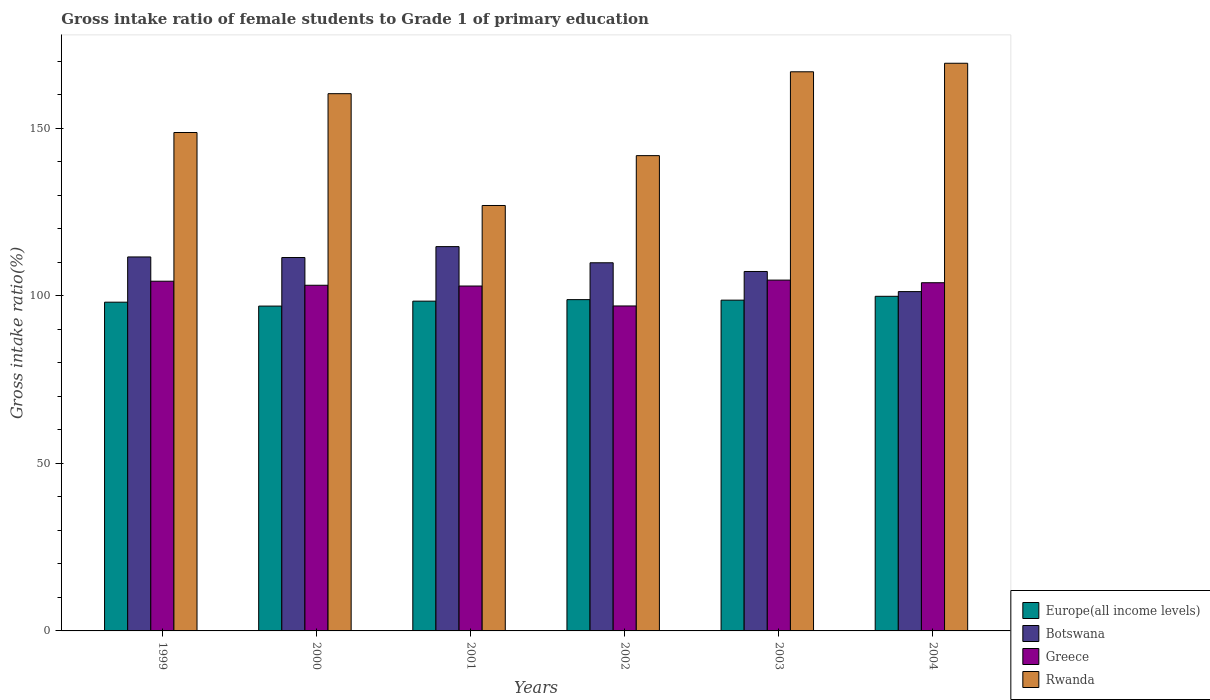How many groups of bars are there?
Offer a very short reply. 6. Are the number of bars on each tick of the X-axis equal?
Offer a very short reply. Yes. What is the label of the 5th group of bars from the left?
Keep it short and to the point. 2003. What is the gross intake ratio in Botswana in 2004?
Provide a succinct answer. 101.23. Across all years, what is the maximum gross intake ratio in Rwanda?
Ensure brevity in your answer.  169.36. Across all years, what is the minimum gross intake ratio in Greece?
Your response must be concise. 96.95. In which year was the gross intake ratio in Europe(all income levels) minimum?
Your answer should be compact. 2000. What is the total gross intake ratio in Botswana in the graph?
Offer a terse response. 655.95. What is the difference between the gross intake ratio in Botswana in 1999 and that in 2002?
Keep it short and to the point. 1.74. What is the difference between the gross intake ratio in Europe(all income levels) in 2001 and the gross intake ratio in Rwanda in 2002?
Offer a very short reply. -43.42. What is the average gross intake ratio in Botswana per year?
Your answer should be very brief. 109.32. In the year 1999, what is the difference between the gross intake ratio in Rwanda and gross intake ratio in Botswana?
Your answer should be very brief. 37.12. In how many years, is the gross intake ratio in Greece greater than 70 %?
Provide a succinct answer. 6. What is the ratio of the gross intake ratio in Rwanda in 2000 to that in 2004?
Provide a short and direct response. 0.95. What is the difference between the highest and the second highest gross intake ratio in Rwanda?
Ensure brevity in your answer.  2.54. What is the difference between the highest and the lowest gross intake ratio in Botswana?
Give a very brief answer. 13.42. What does the 3rd bar from the left in 2004 represents?
Ensure brevity in your answer.  Greece. What does the 1st bar from the right in 2001 represents?
Give a very brief answer. Rwanda. Is it the case that in every year, the sum of the gross intake ratio in Rwanda and gross intake ratio in Greece is greater than the gross intake ratio in Botswana?
Make the answer very short. Yes. How many years are there in the graph?
Ensure brevity in your answer.  6. Are the values on the major ticks of Y-axis written in scientific E-notation?
Your response must be concise. No. How many legend labels are there?
Give a very brief answer. 4. How are the legend labels stacked?
Ensure brevity in your answer.  Vertical. What is the title of the graph?
Your answer should be very brief. Gross intake ratio of female students to Grade 1 of primary education. Does "Papua New Guinea" appear as one of the legend labels in the graph?
Ensure brevity in your answer.  No. What is the label or title of the X-axis?
Your response must be concise. Years. What is the label or title of the Y-axis?
Make the answer very short. Gross intake ratio(%). What is the Gross intake ratio(%) in Europe(all income levels) in 1999?
Provide a succinct answer. 98.08. What is the Gross intake ratio(%) of Botswana in 1999?
Provide a succinct answer. 111.58. What is the Gross intake ratio(%) of Greece in 1999?
Provide a short and direct response. 104.33. What is the Gross intake ratio(%) in Rwanda in 1999?
Give a very brief answer. 148.7. What is the Gross intake ratio(%) in Europe(all income levels) in 2000?
Offer a very short reply. 96.91. What is the Gross intake ratio(%) in Botswana in 2000?
Offer a very short reply. 111.4. What is the Gross intake ratio(%) of Greece in 2000?
Provide a succinct answer. 103.13. What is the Gross intake ratio(%) in Rwanda in 2000?
Keep it short and to the point. 160.29. What is the Gross intake ratio(%) in Europe(all income levels) in 2001?
Provide a short and direct response. 98.39. What is the Gross intake ratio(%) in Botswana in 2001?
Keep it short and to the point. 114.66. What is the Gross intake ratio(%) of Greece in 2001?
Provide a succinct answer. 102.9. What is the Gross intake ratio(%) of Rwanda in 2001?
Provide a short and direct response. 126.92. What is the Gross intake ratio(%) in Europe(all income levels) in 2002?
Give a very brief answer. 98.84. What is the Gross intake ratio(%) of Botswana in 2002?
Offer a terse response. 109.84. What is the Gross intake ratio(%) of Greece in 2002?
Your answer should be very brief. 96.95. What is the Gross intake ratio(%) in Rwanda in 2002?
Make the answer very short. 141.8. What is the Gross intake ratio(%) in Europe(all income levels) in 2003?
Make the answer very short. 98.68. What is the Gross intake ratio(%) of Botswana in 2003?
Your answer should be compact. 107.24. What is the Gross intake ratio(%) of Greece in 2003?
Ensure brevity in your answer.  104.67. What is the Gross intake ratio(%) in Rwanda in 2003?
Ensure brevity in your answer.  166.82. What is the Gross intake ratio(%) of Europe(all income levels) in 2004?
Offer a very short reply. 99.83. What is the Gross intake ratio(%) of Botswana in 2004?
Keep it short and to the point. 101.23. What is the Gross intake ratio(%) of Greece in 2004?
Ensure brevity in your answer.  103.89. What is the Gross intake ratio(%) of Rwanda in 2004?
Make the answer very short. 169.36. Across all years, what is the maximum Gross intake ratio(%) in Europe(all income levels)?
Your answer should be compact. 99.83. Across all years, what is the maximum Gross intake ratio(%) in Botswana?
Keep it short and to the point. 114.66. Across all years, what is the maximum Gross intake ratio(%) of Greece?
Provide a succinct answer. 104.67. Across all years, what is the maximum Gross intake ratio(%) of Rwanda?
Your answer should be compact. 169.36. Across all years, what is the minimum Gross intake ratio(%) in Europe(all income levels)?
Keep it short and to the point. 96.91. Across all years, what is the minimum Gross intake ratio(%) in Botswana?
Your answer should be compact. 101.23. Across all years, what is the minimum Gross intake ratio(%) in Greece?
Ensure brevity in your answer.  96.95. Across all years, what is the minimum Gross intake ratio(%) in Rwanda?
Your answer should be compact. 126.92. What is the total Gross intake ratio(%) in Europe(all income levels) in the graph?
Ensure brevity in your answer.  590.74. What is the total Gross intake ratio(%) of Botswana in the graph?
Offer a terse response. 655.95. What is the total Gross intake ratio(%) in Greece in the graph?
Your answer should be compact. 615.86. What is the total Gross intake ratio(%) of Rwanda in the graph?
Provide a short and direct response. 913.9. What is the difference between the Gross intake ratio(%) of Europe(all income levels) in 1999 and that in 2000?
Provide a short and direct response. 1.17. What is the difference between the Gross intake ratio(%) of Botswana in 1999 and that in 2000?
Make the answer very short. 0.17. What is the difference between the Gross intake ratio(%) of Greece in 1999 and that in 2000?
Provide a succinct answer. 1.21. What is the difference between the Gross intake ratio(%) of Rwanda in 1999 and that in 2000?
Give a very brief answer. -11.58. What is the difference between the Gross intake ratio(%) in Europe(all income levels) in 1999 and that in 2001?
Provide a short and direct response. -0.31. What is the difference between the Gross intake ratio(%) in Botswana in 1999 and that in 2001?
Make the answer very short. -3.08. What is the difference between the Gross intake ratio(%) in Greece in 1999 and that in 2001?
Give a very brief answer. 1.44. What is the difference between the Gross intake ratio(%) of Rwanda in 1999 and that in 2001?
Ensure brevity in your answer.  21.78. What is the difference between the Gross intake ratio(%) of Europe(all income levels) in 1999 and that in 2002?
Provide a succinct answer. -0.76. What is the difference between the Gross intake ratio(%) of Botswana in 1999 and that in 2002?
Keep it short and to the point. 1.74. What is the difference between the Gross intake ratio(%) of Greece in 1999 and that in 2002?
Offer a very short reply. 7.38. What is the difference between the Gross intake ratio(%) of Rwanda in 1999 and that in 2002?
Keep it short and to the point. 6.9. What is the difference between the Gross intake ratio(%) of Europe(all income levels) in 1999 and that in 2003?
Your answer should be compact. -0.6. What is the difference between the Gross intake ratio(%) in Botswana in 1999 and that in 2003?
Make the answer very short. 4.34. What is the difference between the Gross intake ratio(%) in Greece in 1999 and that in 2003?
Your response must be concise. -0.33. What is the difference between the Gross intake ratio(%) of Rwanda in 1999 and that in 2003?
Keep it short and to the point. -18.12. What is the difference between the Gross intake ratio(%) of Europe(all income levels) in 1999 and that in 2004?
Your answer should be very brief. -1.75. What is the difference between the Gross intake ratio(%) of Botswana in 1999 and that in 2004?
Your answer should be very brief. 10.34. What is the difference between the Gross intake ratio(%) in Greece in 1999 and that in 2004?
Ensure brevity in your answer.  0.45. What is the difference between the Gross intake ratio(%) in Rwanda in 1999 and that in 2004?
Your answer should be compact. -20.66. What is the difference between the Gross intake ratio(%) of Europe(all income levels) in 2000 and that in 2001?
Your answer should be compact. -1.47. What is the difference between the Gross intake ratio(%) in Botswana in 2000 and that in 2001?
Your response must be concise. -3.25. What is the difference between the Gross intake ratio(%) in Greece in 2000 and that in 2001?
Keep it short and to the point. 0.23. What is the difference between the Gross intake ratio(%) of Rwanda in 2000 and that in 2001?
Make the answer very short. 33.36. What is the difference between the Gross intake ratio(%) of Europe(all income levels) in 2000 and that in 2002?
Keep it short and to the point. -1.92. What is the difference between the Gross intake ratio(%) of Botswana in 2000 and that in 2002?
Keep it short and to the point. 1.57. What is the difference between the Gross intake ratio(%) of Greece in 2000 and that in 2002?
Offer a terse response. 6.18. What is the difference between the Gross intake ratio(%) of Rwanda in 2000 and that in 2002?
Make the answer very short. 18.48. What is the difference between the Gross intake ratio(%) of Europe(all income levels) in 2000 and that in 2003?
Your answer should be very brief. -1.77. What is the difference between the Gross intake ratio(%) in Botswana in 2000 and that in 2003?
Your response must be concise. 4.16. What is the difference between the Gross intake ratio(%) of Greece in 2000 and that in 2003?
Your answer should be very brief. -1.54. What is the difference between the Gross intake ratio(%) of Rwanda in 2000 and that in 2003?
Provide a short and direct response. -6.53. What is the difference between the Gross intake ratio(%) of Europe(all income levels) in 2000 and that in 2004?
Ensure brevity in your answer.  -2.92. What is the difference between the Gross intake ratio(%) of Botswana in 2000 and that in 2004?
Give a very brief answer. 10.17. What is the difference between the Gross intake ratio(%) of Greece in 2000 and that in 2004?
Ensure brevity in your answer.  -0.76. What is the difference between the Gross intake ratio(%) in Rwanda in 2000 and that in 2004?
Keep it short and to the point. -9.08. What is the difference between the Gross intake ratio(%) of Europe(all income levels) in 2001 and that in 2002?
Offer a terse response. -0.45. What is the difference between the Gross intake ratio(%) of Botswana in 2001 and that in 2002?
Your answer should be very brief. 4.82. What is the difference between the Gross intake ratio(%) in Greece in 2001 and that in 2002?
Offer a very short reply. 5.95. What is the difference between the Gross intake ratio(%) of Rwanda in 2001 and that in 2002?
Ensure brevity in your answer.  -14.88. What is the difference between the Gross intake ratio(%) in Europe(all income levels) in 2001 and that in 2003?
Your answer should be compact. -0.3. What is the difference between the Gross intake ratio(%) of Botswana in 2001 and that in 2003?
Your response must be concise. 7.42. What is the difference between the Gross intake ratio(%) in Greece in 2001 and that in 2003?
Keep it short and to the point. -1.77. What is the difference between the Gross intake ratio(%) of Rwanda in 2001 and that in 2003?
Offer a terse response. -39.89. What is the difference between the Gross intake ratio(%) in Europe(all income levels) in 2001 and that in 2004?
Your answer should be very brief. -1.45. What is the difference between the Gross intake ratio(%) in Botswana in 2001 and that in 2004?
Give a very brief answer. 13.42. What is the difference between the Gross intake ratio(%) of Greece in 2001 and that in 2004?
Provide a short and direct response. -0.99. What is the difference between the Gross intake ratio(%) in Rwanda in 2001 and that in 2004?
Ensure brevity in your answer.  -42.44. What is the difference between the Gross intake ratio(%) in Europe(all income levels) in 2002 and that in 2003?
Your answer should be very brief. 0.15. What is the difference between the Gross intake ratio(%) of Botswana in 2002 and that in 2003?
Give a very brief answer. 2.6. What is the difference between the Gross intake ratio(%) of Greece in 2002 and that in 2003?
Provide a succinct answer. -7.72. What is the difference between the Gross intake ratio(%) in Rwanda in 2002 and that in 2003?
Offer a terse response. -25.01. What is the difference between the Gross intake ratio(%) in Europe(all income levels) in 2002 and that in 2004?
Offer a terse response. -0.99. What is the difference between the Gross intake ratio(%) in Botswana in 2002 and that in 2004?
Keep it short and to the point. 8.6. What is the difference between the Gross intake ratio(%) in Greece in 2002 and that in 2004?
Your response must be concise. -6.94. What is the difference between the Gross intake ratio(%) of Rwanda in 2002 and that in 2004?
Offer a very short reply. -27.56. What is the difference between the Gross intake ratio(%) of Europe(all income levels) in 2003 and that in 2004?
Your answer should be compact. -1.15. What is the difference between the Gross intake ratio(%) in Botswana in 2003 and that in 2004?
Your response must be concise. 6. What is the difference between the Gross intake ratio(%) of Greece in 2003 and that in 2004?
Offer a very short reply. 0.78. What is the difference between the Gross intake ratio(%) in Rwanda in 2003 and that in 2004?
Offer a terse response. -2.54. What is the difference between the Gross intake ratio(%) of Europe(all income levels) in 1999 and the Gross intake ratio(%) of Botswana in 2000?
Your answer should be compact. -13.32. What is the difference between the Gross intake ratio(%) in Europe(all income levels) in 1999 and the Gross intake ratio(%) in Greece in 2000?
Make the answer very short. -5.05. What is the difference between the Gross intake ratio(%) in Europe(all income levels) in 1999 and the Gross intake ratio(%) in Rwanda in 2000?
Give a very brief answer. -62.21. What is the difference between the Gross intake ratio(%) in Botswana in 1999 and the Gross intake ratio(%) in Greece in 2000?
Provide a succinct answer. 8.45. What is the difference between the Gross intake ratio(%) in Botswana in 1999 and the Gross intake ratio(%) in Rwanda in 2000?
Make the answer very short. -48.71. What is the difference between the Gross intake ratio(%) in Greece in 1999 and the Gross intake ratio(%) in Rwanda in 2000?
Provide a succinct answer. -55.95. What is the difference between the Gross intake ratio(%) of Europe(all income levels) in 1999 and the Gross intake ratio(%) of Botswana in 2001?
Give a very brief answer. -16.58. What is the difference between the Gross intake ratio(%) of Europe(all income levels) in 1999 and the Gross intake ratio(%) of Greece in 2001?
Offer a very short reply. -4.82. What is the difference between the Gross intake ratio(%) in Europe(all income levels) in 1999 and the Gross intake ratio(%) in Rwanda in 2001?
Provide a short and direct response. -28.84. What is the difference between the Gross intake ratio(%) in Botswana in 1999 and the Gross intake ratio(%) in Greece in 2001?
Keep it short and to the point. 8.68. What is the difference between the Gross intake ratio(%) of Botswana in 1999 and the Gross intake ratio(%) of Rwanda in 2001?
Your answer should be compact. -15.35. What is the difference between the Gross intake ratio(%) of Greece in 1999 and the Gross intake ratio(%) of Rwanda in 2001?
Give a very brief answer. -22.59. What is the difference between the Gross intake ratio(%) in Europe(all income levels) in 1999 and the Gross intake ratio(%) in Botswana in 2002?
Ensure brevity in your answer.  -11.76. What is the difference between the Gross intake ratio(%) in Europe(all income levels) in 1999 and the Gross intake ratio(%) in Greece in 2002?
Offer a very short reply. 1.13. What is the difference between the Gross intake ratio(%) of Europe(all income levels) in 1999 and the Gross intake ratio(%) of Rwanda in 2002?
Give a very brief answer. -43.72. What is the difference between the Gross intake ratio(%) of Botswana in 1999 and the Gross intake ratio(%) of Greece in 2002?
Provide a succinct answer. 14.63. What is the difference between the Gross intake ratio(%) in Botswana in 1999 and the Gross intake ratio(%) in Rwanda in 2002?
Your answer should be very brief. -30.23. What is the difference between the Gross intake ratio(%) of Greece in 1999 and the Gross intake ratio(%) of Rwanda in 2002?
Offer a very short reply. -37.47. What is the difference between the Gross intake ratio(%) of Europe(all income levels) in 1999 and the Gross intake ratio(%) of Botswana in 2003?
Your answer should be very brief. -9.16. What is the difference between the Gross intake ratio(%) of Europe(all income levels) in 1999 and the Gross intake ratio(%) of Greece in 2003?
Your answer should be compact. -6.59. What is the difference between the Gross intake ratio(%) in Europe(all income levels) in 1999 and the Gross intake ratio(%) in Rwanda in 2003?
Make the answer very short. -68.74. What is the difference between the Gross intake ratio(%) in Botswana in 1999 and the Gross intake ratio(%) in Greece in 2003?
Give a very brief answer. 6.91. What is the difference between the Gross intake ratio(%) of Botswana in 1999 and the Gross intake ratio(%) of Rwanda in 2003?
Your response must be concise. -55.24. What is the difference between the Gross intake ratio(%) of Greece in 1999 and the Gross intake ratio(%) of Rwanda in 2003?
Provide a succinct answer. -62.48. What is the difference between the Gross intake ratio(%) of Europe(all income levels) in 1999 and the Gross intake ratio(%) of Botswana in 2004?
Make the answer very short. -3.15. What is the difference between the Gross intake ratio(%) in Europe(all income levels) in 1999 and the Gross intake ratio(%) in Greece in 2004?
Offer a terse response. -5.8. What is the difference between the Gross intake ratio(%) of Europe(all income levels) in 1999 and the Gross intake ratio(%) of Rwanda in 2004?
Make the answer very short. -71.28. What is the difference between the Gross intake ratio(%) in Botswana in 1999 and the Gross intake ratio(%) in Greece in 2004?
Provide a succinct answer. 7.69. What is the difference between the Gross intake ratio(%) of Botswana in 1999 and the Gross intake ratio(%) of Rwanda in 2004?
Ensure brevity in your answer.  -57.78. What is the difference between the Gross intake ratio(%) in Greece in 1999 and the Gross intake ratio(%) in Rwanda in 2004?
Give a very brief answer. -65.03. What is the difference between the Gross intake ratio(%) of Europe(all income levels) in 2000 and the Gross intake ratio(%) of Botswana in 2001?
Make the answer very short. -17.74. What is the difference between the Gross intake ratio(%) of Europe(all income levels) in 2000 and the Gross intake ratio(%) of Greece in 2001?
Ensure brevity in your answer.  -5.98. What is the difference between the Gross intake ratio(%) in Europe(all income levels) in 2000 and the Gross intake ratio(%) in Rwanda in 2001?
Make the answer very short. -30.01. What is the difference between the Gross intake ratio(%) in Botswana in 2000 and the Gross intake ratio(%) in Greece in 2001?
Give a very brief answer. 8.5. What is the difference between the Gross intake ratio(%) in Botswana in 2000 and the Gross intake ratio(%) in Rwanda in 2001?
Your answer should be compact. -15.52. What is the difference between the Gross intake ratio(%) in Greece in 2000 and the Gross intake ratio(%) in Rwanda in 2001?
Offer a very short reply. -23.8. What is the difference between the Gross intake ratio(%) in Europe(all income levels) in 2000 and the Gross intake ratio(%) in Botswana in 2002?
Ensure brevity in your answer.  -12.92. What is the difference between the Gross intake ratio(%) of Europe(all income levels) in 2000 and the Gross intake ratio(%) of Greece in 2002?
Your response must be concise. -0.04. What is the difference between the Gross intake ratio(%) in Europe(all income levels) in 2000 and the Gross intake ratio(%) in Rwanda in 2002?
Give a very brief answer. -44.89. What is the difference between the Gross intake ratio(%) in Botswana in 2000 and the Gross intake ratio(%) in Greece in 2002?
Provide a short and direct response. 14.45. What is the difference between the Gross intake ratio(%) of Botswana in 2000 and the Gross intake ratio(%) of Rwanda in 2002?
Ensure brevity in your answer.  -30.4. What is the difference between the Gross intake ratio(%) of Greece in 2000 and the Gross intake ratio(%) of Rwanda in 2002?
Offer a terse response. -38.67. What is the difference between the Gross intake ratio(%) of Europe(all income levels) in 2000 and the Gross intake ratio(%) of Botswana in 2003?
Ensure brevity in your answer.  -10.32. What is the difference between the Gross intake ratio(%) in Europe(all income levels) in 2000 and the Gross intake ratio(%) in Greece in 2003?
Provide a short and direct response. -7.75. What is the difference between the Gross intake ratio(%) of Europe(all income levels) in 2000 and the Gross intake ratio(%) of Rwanda in 2003?
Make the answer very short. -69.9. What is the difference between the Gross intake ratio(%) in Botswana in 2000 and the Gross intake ratio(%) in Greece in 2003?
Your answer should be compact. 6.74. What is the difference between the Gross intake ratio(%) of Botswana in 2000 and the Gross intake ratio(%) of Rwanda in 2003?
Offer a very short reply. -55.41. What is the difference between the Gross intake ratio(%) in Greece in 2000 and the Gross intake ratio(%) in Rwanda in 2003?
Offer a very short reply. -63.69. What is the difference between the Gross intake ratio(%) in Europe(all income levels) in 2000 and the Gross intake ratio(%) in Botswana in 2004?
Offer a very short reply. -4.32. What is the difference between the Gross intake ratio(%) in Europe(all income levels) in 2000 and the Gross intake ratio(%) in Greece in 2004?
Your answer should be compact. -6.97. What is the difference between the Gross intake ratio(%) in Europe(all income levels) in 2000 and the Gross intake ratio(%) in Rwanda in 2004?
Your response must be concise. -72.45. What is the difference between the Gross intake ratio(%) of Botswana in 2000 and the Gross intake ratio(%) of Greece in 2004?
Make the answer very short. 7.52. What is the difference between the Gross intake ratio(%) in Botswana in 2000 and the Gross intake ratio(%) in Rwanda in 2004?
Your response must be concise. -57.96. What is the difference between the Gross intake ratio(%) in Greece in 2000 and the Gross intake ratio(%) in Rwanda in 2004?
Provide a short and direct response. -66.23. What is the difference between the Gross intake ratio(%) of Europe(all income levels) in 2001 and the Gross intake ratio(%) of Botswana in 2002?
Offer a very short reply. -11.45. What is the difference between the Gross intake ratio(%) of Europe(all income levels) in 2001 and the Gross intake ratio(%) of Greece in 2002?
Your answer should be compact. 1.44. What is the difference between the Gross intake ratio(%) of Europe(all income levels) in 2001 and the Gross intake ratio(%) of Rwanda in 2002?
Offer a very short reply. -43.42. What is the difference between the Gross intake ratio(%) of Botswana in 2001 and the Gross intake ratio(%) of Greece in 2002?
Your answer should be very brief. 17.71. What is the difference between the Gross intake ratio(%) of Botswana in 2001 and the Gross intake ratio(%) of Rwanda in 2002?
Your answer should be very brief. -27.15. What is the difference between the Gross intake ratio(%) in Greece in 2001 and the Gross intake ratio(%) in Rwanda in 2002?
Ensure brevity in your answer.  -38.9. What is the difference between the Gross intake ratio(%) of Europe(all income levels) in 2001 and the Gross intake ratio(%) of Botswana in 2003?
Make the answer very short. -8.85. What is the difference between the Gross intake ratio(%) in Europe(all income levels) in 2001 and the Gross intake ratio(%) in Greece in 2003?
Your answer should be compact. -6.28. What is the difference between the Gross intake ratio(%) in Europe(all income levels) in 2001 and the Gross intake ratio(%) in Rwanda in 2003?
Give a very brief answer. -68.43. What is the difference between the Gross intake ratio(%) of Botswana in 2001 and the Gross intake ratio(%) of Greece in 2003?
Provide a short and direct response. 9.99. What is the difference between the Gross intake ratio(%) in Botswana in 2001 and the Gross intake ratio(%) in Rwanda in 2003?
Offer a terse response. -52.16. What is the difference between the Gross intake ratio(%) in Greece in 2001 and the Gross intake ratio(%) in Rwanda in 2003?
Provide a short and direct response. -63.92. What is the difference between the Gross intake ratio(%) in Europe(all income levels) in 2001 and the Gross intake ratio(%) in Botswana in 2004?
Provide a succinct answer. -2.85. What is the difference between the Gross intake ratio(%) in Europe(all income levels) in 2001 and the Gross intake ratio(%) in Greece in 2004?
Offer a terse response. -5.5. What is the difference between the Gross intake ratio(%) of Europe(all income levels) in 2001 and the Gross intake ratio(%) of Rwanda in 2004?
Offer a very short reply. -70.98. What is the difference between the Gross intake ratio(%) of Botswana in 2001 and the Gross intake ratio(%) of Greece in 2004?
Your response must be concise. 10.77. What is the difference between the Gross intake ratio(%) in Botswana in 2001 and the Gross intake ratio(%) in Rwanda in 2004?
Provide a succinct answer. -54.71. What is the difference between the Gross intake ratio(%) of Greece in 2001 and the Gross intake ratio(%) of Rwanda in 2004?
Keep it short and to the point. -66.46. What is the difference between the Gross intake ratio(%) of Europe(all income levels) in 2002 and the Gross intake ratio(%) of Botswana in 2003?
Ensure brevity in your answer.  -8.4. What is the difference between the Gross intake ratio(%) of Europe(all income levels) in 2002 and the Gross intake ratio(%) of Greece in 2003?
Offer a terse response. -5.83. What is the difference between the Gross intake ratio(%) in Europe(all income levels) in 2002 and the Gross intake ratio(%) in Rwanda in 2003?
Provide a short and direct response. -67.98. What is the difference between the Gross intake ratio(%) in Botswana in 2002 and the Gross intake ratio(%) in Greece in 2003?
Make the answer very short. 5.17. What is the difference between the Gross intake ratio(%) in Botswana in 2002 and the Gross intake ratio(%) in Rwanda in 2003?
Ensure brevity in your answer.  -56.98. What is the difference between the Gross intake ratio(%) of Greece in 2002 and the Gross intake ratio(%) of Rwanda in 2003?
Offer a terse response. -69.87. What is the difference between the Gross intake ratio(%) of Europe(all income levels) in 2002 and the Gross intake ratio(%) of Botswana in 2004?
Offer a terse response. -2.4. What is the difference between the Gross intake ratio(%) of Europe(all income levels) in 2002 and the Gross intake ratio(%) of Greece in 2004?
Keep it short and to the point. -5.05. What is the difference between the Gross intake ratio(%) of Europe(all income levels) in 2002 and the Gross intake ratio(%) of Rwanda in 2004?
Keep it short and to the point. -70.52. What is the difference between the Gross intake ratio(%) in Botswana in 2002 and the Gross intake ratio(%) in Greece in 2004?
Offer a terse response. 5.95. What is the difference between the Gross intake ratio(%) of Botswana in 2002 and the Gross intake ratio(%) of Rwanda in 2004?
Offer a terse response. -59.53. What is the difference between the Gross intake ratio(%) in Greece in 2002 and the Gross intake ratio(%) in Rwanda in 2004?
Ensure brevity in your answer.  -72.41. What is the difference between the Gross intake ratio(%) of Europe(all income levels) in 2003 and the Gross intake ratio(%) of Botswana in 2004?
Your answer should be compact. -2.55. What is the difference between the Gross intake ratio(%) of Europe(all income levels) in 2003 and the Gross intake ratio(%) of Greece in 2004?
Your answer should be very brief. -5.2. What is the difference between the Gross intake ratio(%) of Europe(all income levels) in 2003 and the Gross intake ratio(%) of Rwanda in 2004?
Your response must be concise. -70.68. What is the difference between the Gross intake ratio(%) of Botswana in 2003 and the Gross intake ratio(%) of Greece in 2004?
Your answer should be compact. 3.35. What is the difference between the Gross intake ratio(%) of Botswana in 2003 and the Gross intake ratio(%) of Rwanda in 2004?
Offer a very short reply. -62.12. What is the difference between the Gross intake ratio(%) in Greece in 2003 and the Gross intake ratio(%) in Rwanda in 2004?
Make the answer very short. -64.69. What is the average Gross intake ratio(%) of Europe(all income levels) per year?
Your answer should be compact. 98.46. What is the average Gross intake ratio(%) in Botswana per year?
Your response must be concise. 109.32. What is the average Gross intake ratio(%) in Greece per year?
Make the answer very short. 102.64. What is the average Gross intake ratio(%) of Rwanda per year?
Your response must be concise. 152.32. In the year 1999, what is the difference between the Gross intake ratio(%) in Europe(all income levels) and Gross intake ratio(%) in Botswana?
Make the answer very short. -13.5. In the year 1999, what is the difference between the Gross intake ratio(%) in Europe(all income levels) and Gross intake ratio(%) in Greece?
Offer a terse response. -6.25. In the year 1999, what is the difference between the Gross intake ratio(%) in Europe(all income levels) and Gross intake ratio(%) in Rwanda?
Provide a succinct answer. -50.62. In the year 1999, what is the difference between the Gross intake ratio(%) of Botswana and Gross intake ratio(%) of Greece?
Ensure brevity in your answer.  7.24. In the year 1999, what is the difference between the Gross intake ratio(%) in Botswana and Gross intake ratio(%) in Rwanda?
Give a very brief answer. -37.12. In the year 1999, what is the difference between the Gross intake ratio(%) of Greece and Gross intake ratio(%) of Rwanda?
Ensure brevity in your answer.  -44.37. In the year 2000, what is the difference between the Gross intake ratio(%) in Europe(all income levels) and Gross intake ratio(%) in Botswana?
Ensure brevity in your answer.  -14.49. In the year 2000, what is the difference between the Gross intake ratio(%) in Europe(all income levels) and Gross intake ratio(%) in Greece?
Provide a succinct answer. -6.21. In the year 2000, what is the difference between the Gross intake ratio(%) of Europe(all income levels) and Gross intake ratio(%) of Rwanda?
Your response must be concise. -63.37. In the year 2000, what is the difference between the Gross intake ratio(%) of Botswana and Gross intake ratio(%) of Greece?
Your answer should be compact. 8.28. In the year 2000, what is the difference between the Gross intake ratio(%) of Botswana and Gross intake ratio(%) of Rwanda?
Ensure brevity in your answer.  -48.88. In the year 2000, what is the difference between the Gross intake ratio(%) of Greece and Gross intake ratio(%) of Rwanda?
Make the answer very short. -57.16. In the year 2001, what is the difference between the Gross intake ratio(%) of Europe(all income levels) and Gross intake ratio(%) of Botswana?
Your answer should be very brief. -16.27. In the year 2001, what is the difference between the Gross intake ratio(%) of Europe(all income levels) and Gross intake ratio(%) of Greece?
Keep it short and to the point. -4.51. In the year 2001, what is the difference between the Gross intake ratio(%) of Europe(all income levels) and Gross intake ratio(%) of Rwanda?
Offer a very short reply. -28.54. In the year 2001, what is the difference between the Gross intake ratio(%) of Botswana and Gross intake ratio(%) of Greece?
Your answer should be very brief. 11.76. In the year 2001, what is the difference between the Gross intake ratio(%) of Botswana and Gross intake ratio(%) of Rwanda?
Offer a terse response. -12.27. In the year 2001, what is the difference between the Gross intake ratio(%) in Greece and Gross intake ratio(%) in Rwanda?
Provide a short and direct response. -24.03. In the year 2002, what is the difference between the Gross intake ratio(%) in Europe(all income levels) and Gross intake ratio(%) in Botswana?
Ensure brevity in your answer.  -11. In the year 2002, what is the difference between the Gross intake ratio(%) in Europe(all income levels) and Gross intake ratio(%) in Greece?
Your answer should be compact. 1.89. In the year 2002, what is the difference between the Gross intake ratio(%) in Europe(all income levels) and Gross intake ratio(%) in Rwanda?
Keep it short and to the point. -42.97. In the year 2002, what is the difference between the Gross intake ratio(%) of Botswana and Gross intake ratio(%) of Greece?
Keep it short and to the point. 12.89. In the year 2002, what is the difference between the Gross intake ratio(%) in Botswana and Gross intake ratio(%) in Rwanda?
Offer a terse response. -31.97. In the year 2002, what is the difference between the Gross intake ratio(%) of Greece and Gross intake ratio(%) of Rwanda?
Your answer should be compact. -44.85. In the year 2003, what is the difference between the Gross intake ratio(%) of Europe(all income levels) and Gross intake ratio(%) of Botswana?
Ensure brevity in your answer.  -8.55. In the year 2003, what is the difference between the Gross intake ratio(%) in Europe(all income levels) and Gross intake ratio(%) in Greece?
Your response must be concise. -5.98. In the year 2003, what is the difference between the Gross intake ratio(%) of Europe(all income levels) and Gross intake ratio(%) of Rwanda?
Your response must be concise. -68.13. In the year 2003, what is the difference between the Gross intake ratio(%) of Botswana and Gross intake ratio(%) of Greece?
Your response must be concise. 2.57. In the year 2003, what is the difference between the Gross intake ratio(%) in Botswana and Gross intake ratio(%) in Rwanda?
Ensure brevity in your answer.  -59.58. In the year 2003, what is the difference between the Gross intake ratio(%) in Greece and Gross intake ratio(%) in Rwanda?
Keep it short and to the point. -62.15. In the year 2004, what is the difference between the Gross intake ratio(%) in Europe(all income levels) and Gross intake ratio(%) in Botswana?
Keep it short and to the point. -1.4. In the year 2004, what is the difference between the Gross intake ratio(%) of Europe(all income levels) and Gross intake ratio(%) of Greece?
Your response must be concise. -4.05. In the year 2004, what is the difference between the Gross intake ratio(%) of Europe(all income levels) and Gross intake ratio(%) of Rwanda?
Your answer should be very brief. -69.53. In the year 2004, what is the difference between the Gross intake ratio(%) in Botswana and Gross intake ratio(%) in Greece?
Keep it short and to the point. -2.65. In the year 2004, what is the difference between the Gross intake ratio(%) of Botswana and Gross intake ratio(%) of Rwanda?
Offer a terse response. -68.13. In the year 2004, what is the difference between the Gross intake ratio(%) in Greece and Gross intake ratio(%) in Rwanda?
Offer a terse response. -65.48. What is the ratio of the Gross intake ratio(%) in Botswana in 1999 to that in 2000?
Your response must be concise. 1. What is the ratio of the Gross intake ratio(%) of Greece in 1999 to that in 2000?
Provide a short and direct response. 1.01. What is the ratio of the Gross intake ratio(%) of Rwanda in 1999 to that in 2000?
Make the answer very short. 0.93. What is the ratio of the Gross intake ratio(%) in Botswana in 1999 to that in 2001?
Ensure brevity in your answer.  0.97. What is the ratio of the Gross intake ratio(%) of Greece in 1999 to that in 2001?
Offer a terse response. 1.01. What is the ratio of the Gross intake ratio(%) of Rwanda in 1999 to that in 2001?
Ensure brevity in your answer.  1.17. What is the ratio of the Gross intake ratio(%) of Botswana in 1999 to that in 2002?
Give a very brief answer. 1.02. What is the ratio of the Gross intake ratio(%) of Greece in 1999 to that in 2002?
Provide a succinct answer. 1.08. What is the ratio of the Gross intake ratio(%) of Rwanda in 1999 to that in 2002?
Give a very brief answer. 1.05. What is the ratio of the Gross intake ratio(%) of Botswana in 1999 to that in 2003?
Give a very brief answer. 1.04. What is the ratio of the Gross intake ratio(%) in Greece in 1999 to that in 2003?
Your answer should be compact. 1. What is the ratio of the Gross intake ratio(%) of Rwanda in 1999 to that in 2003?
Ensure brevity in your answer.  0.89. What is the ratio of the Gross intake ratio(%) in Europe(all income levels) in 1999 to that in 2004?
Offer a very short reply. 0.98. What is the ratio of the Gross intake ratio(%) of Botswana in 1999 to that in 2004?
Offer a very short reply. 1.1. What is the ratio of the Gross intake ratio(%) of Greece in 1999 to that in 2004?
Keep it short and to the point. 1. What is the ratio of the Gross intake ratio(%) in Rwanda in 1999 to that in 2004?
Your response must be concise. 0.88. What is the ratio of the Gross intake ratio(%) of Botswana in 2000 to that in 2001?
Offer a terse response. 0.97. What is the ratio of the Gross intake ratio(%) of Greece in 2000 to that in 2001?
Provide a succinct answer. 1. What is the ratio of the Gross intake ratio(%) in Rwanda in 2000 to that in 2001?
Your response must be concise. 1.26. What is the ratio of the Gross intake ratio(%) of Europe(all income levels) in 2000 to that in 2002?
Provide a succinct answer. 0.98. What is the ratio of the Gross intake ratio(%) in Botswana in 2000 to that in 2002?
Offer a very short reply. 1.01. What is the ratio of the Gross intake ratio(%) in Greece in 2000 to that in 2002?
Your answer should be compact. 1.06. What is the ratio of the Gross intake ratio(%) of Rwanda in 2000 to that in 2002?
Offer a very short reply. 1.13. What is the ratio of the Gross intake ratio(%) of Europe(all income levels) in 2000 to that in 2003?
Your answer should be very brief. 0.98. What is the ratio of the Gross intake ratio(%) of Botswana in 2000 to that in 2003?
Your response must be concise. 1.04. What is the ratio of the Gross intake ratio(%) in Greece in 2000 to that in 2003?
Keep it short and to the point. 0.99. What is the ratio of the Gross intake ratio(%) in Rwanda in 2000 to that in 2003?
Your response must be concise. 0.96. What is the ratio of the Gross intake ratio(%) in Europe(all income levels) in 2000 to that in 2004?
Your response must be concise. 0.97. What is the ratio of the Gross intake ratio(%) in Botswana in 2000 to that in 2004?
Ensure brevity in your answer.  1.1. What is the ratio of the Gross intake ratio(%) in Rwanda in 2000 to that in 2004?
Your response must be concise. 0.95. What is the ratio of the Gross intake ratio(%) in Botswana in 2001 to that in 2002?
Make the answer very short. 1.04. What is the ratio of the Gross intake ratio(%) in Greece in 2001 to that in 2002?
Keep it short and to the point. 1.06. What is the ratio of the Gross intake ratio(%) in Rwanda in 2001 to that in 2002?
Give a very brief answer. 0.9. What is the ratio of the Gross intake ratio(%) of Europe(all income levels) in 2001 to that in 2003?
Make the answer very short. 1. What is the ratio of the Gross intake ratio(%) in Botswana in 2001 to that in 2003?
Provide a short and direct response. 1.07. What is the ratio of the Gross intake ratio(%) in Greece in 2001 to that in 2003?
Provide a succinct answer. 0.98. What is the ratio of the Gross intake ratio(%) in Rwanda in 2001 to that in 2003?
Your response must be concise. 0.76. What is the ratio of the Gross intake ratio(%) in Europe(all income levels) in 2001 to that in 2004?
Your answer should be compact. 0.99. What is the ratio of the Gross intake ratio(%) of Botswana in 2001 to that in 2004?
Offer a terse response. 1.13. What is the ratio of the Gross intake ratio(%) of Greece in 2001 to that in 2004?
Provide a short and direct response. 0.99. What is the ratio of the Gross intake ratio(%) in Rwanda in 2001 to that in 2004?
Your answer should be very brief. 0.75. What is the ratio of the Gross intake ratio(%) in Botswana in 2002 to that in 2003?
Your answer should be very brief. 1.02. What is the ratio of the Gross intake ratio(%) of Greece in 2002 to that in 2003?
Your answer should be very brief. 0.93. What is the ratio of the Gross intake ratio(%) in Botswana in 2002 to that in 2004?
Provide a succinct answer. 1.08. What is the ratio of the Gross intake ratio(%) of Greece in 2002 to that in 2004?
Your response must be concise. 0.93. What is the ratio of the Gross intake ratio(%) of Rwanda in 2002 to that in 2004?
Make the answer very short. 0.84. What is the ratio of the Gross intake ratio(%) in Europe(all income levels) in 2003 to that in 2004?
Offer a very short reply. 0.99. What is the ratio of the Gross intake ratio(%) in Botswana in 2003 to that in 2004?
Provide a short and direct response. 1.06. What is the ratio of the Gross intake ratio(%) in Greece in 2003 to that in 2004?
Ensure brevity in your answer.  1.01. What is the difference between the highest and the second highest Gross intake ratio(%) of Botswana?
Ensure brevity in your answer.  3.08. What is the difference between the highest and the second highest Gross intake ratio(%) in Greece?
Provide a short and direct response. 0.33. What is the difference between the highest and the second highest Gross intake ratio(%) in Rwanda?
Make the answer very short. 2.54. What is the difference between the highest and the lowest Gross intake ratio(%) of Europe(all income levels)?
Your response must be concise. 2.92. What is the difference between the highest and the lowest Gross intake ratio(%) in Botswana?
Keep it short and to the point. 13.42. What is the difference between the highest and the lowest Gross intake ratio(%) of Greece?
Offer a terse response. 7.72. What is the difference between the highest and the lowest Gross intake ratio(%) in Rwanda?
Give a very brief answer. 42.44. 